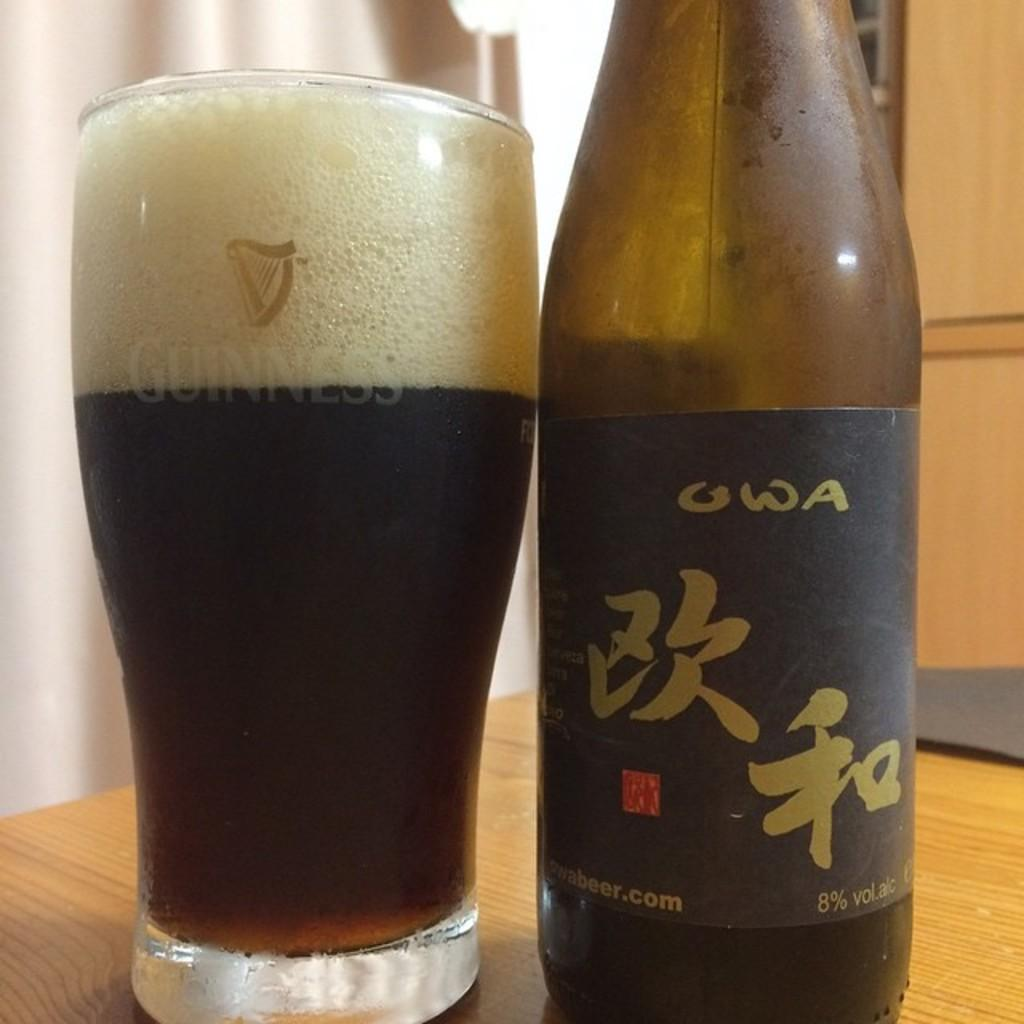<image>
Relay a brief, clear account of the picture shown. A beer bottle sits next to a glass that reads Guinness. 